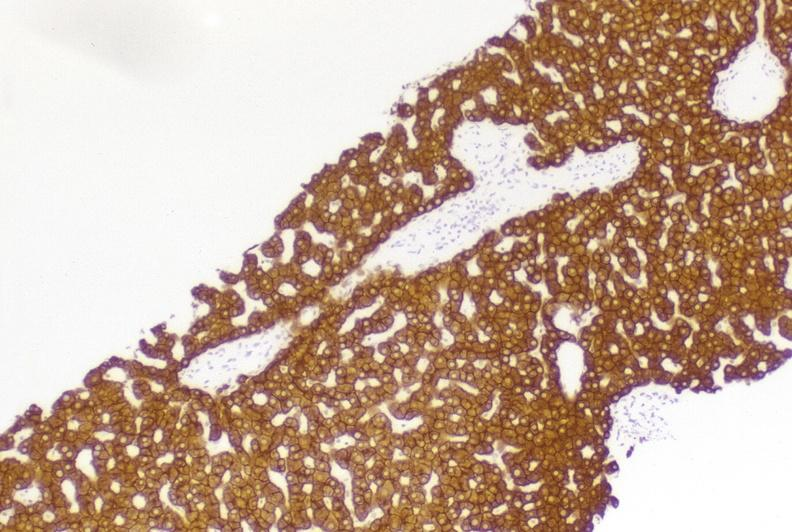what is present?
Answer the question using a single word or phrase. Liver 